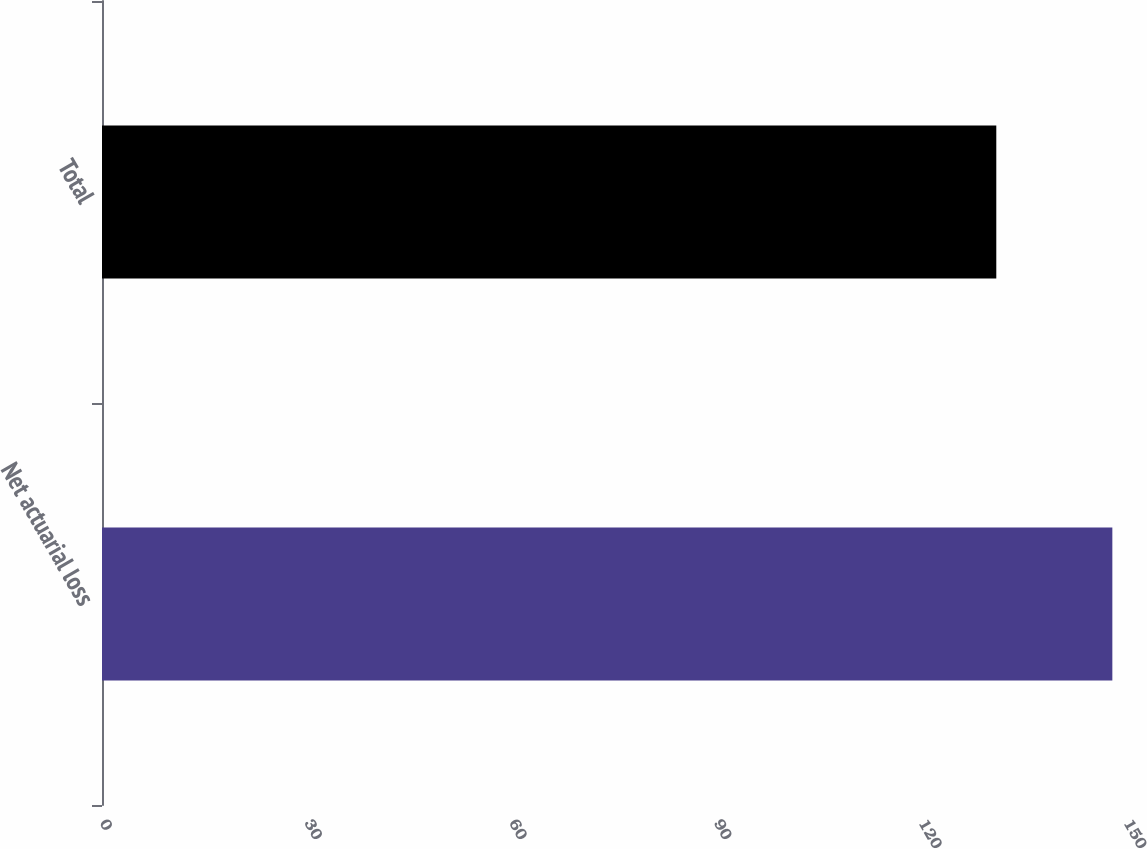<chart> <loc_0><loc_0><loc_500><loc_500><bar_chart><fcel>Net actuarial loss<fcel>Total<nl><fcel>148<fcel>131<nl></chart> 